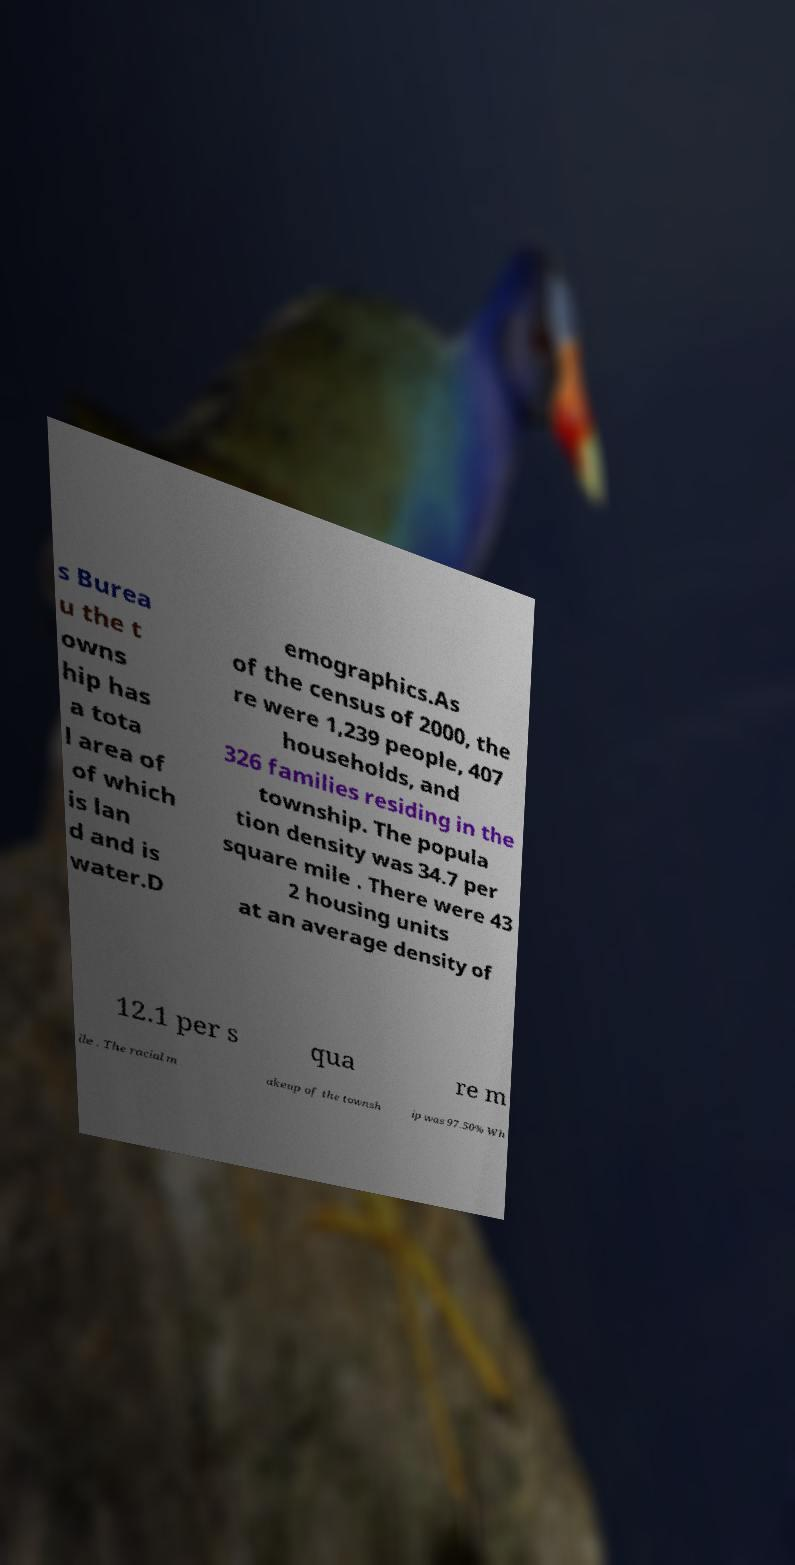Please identify and transcribe the text found in this image. s Burea u the t owns hip has a tota l area of of which is lan d and is water.D emographics.As of the census of 2000, the re were 1,239 people, 407 households, and 326 families residing in the township. The popula tion density was 34.7 per square mile . There were 43 2 housing units at an average density of 12.1 per s qua re m ile . The racial m akeup of the townsh ip was 97.50% Wh 